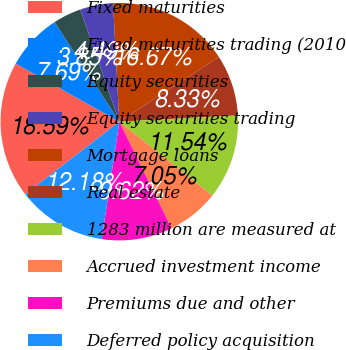<chart> <loc_0><loc_0><loc_500><loc_500><pie_chart><fcel>Fixed maturities<fcel>Fixed maturities trading (2010<fcel>Equity securities<fcel>Equity securities trading<fcel>Mortgage loans<fcel>Real estate<fcel>1283 million are measured at<fcel>Accrued investment income<fcel>Premiums due and other<fcel>Deferred policy acquisition<nl><fcel>18.59%<fcel>7.69%<fcel>3.85%<fcel>4.49%<fcel>16.67%<fcel>8.33%<fcel>11.54%<fcel>7.05%<fcel>9.62%<fcel>12.18%<nl></chart> 